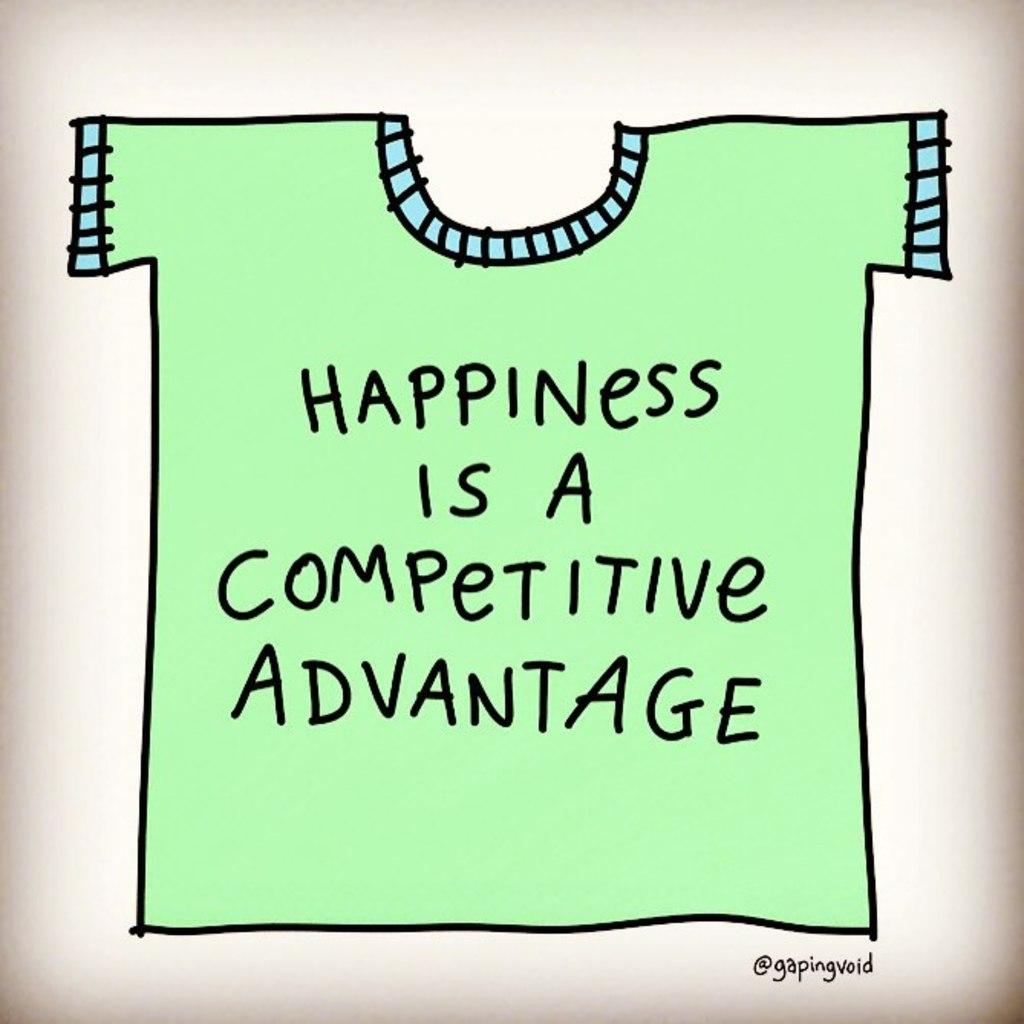What is depicted in the image? There is a drawing of a t-shirt in the image. What color is the t-shirt? The t-shirt is green in color. What is written on the t-shirt? There is text on the t-shirt. What color is the text on the t-shirt? The text is black in color. Can you see any clouds in the image? There are no clouds present in the image; it features a drawing of a t-shirt. Is there any destruction happening in the image? There is no destruction depicted in the image; it features a drawing of a t-shirt with text on it. 